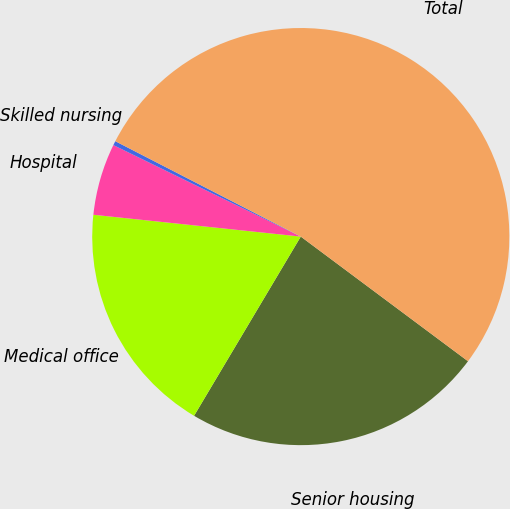Convert chart. <chart><loc_0><loc_0><loc_500><loc_500><pie_chart><fcel>Senior housing<fcel>Medical office<fcel>Hospital<fcel>Skilled nursing<fcel>Total<nl><fcel>23.35%<fcel>18.12%<fcel>5.56%<fcel>0.33%<fcel>52.63%<nl></chart> 